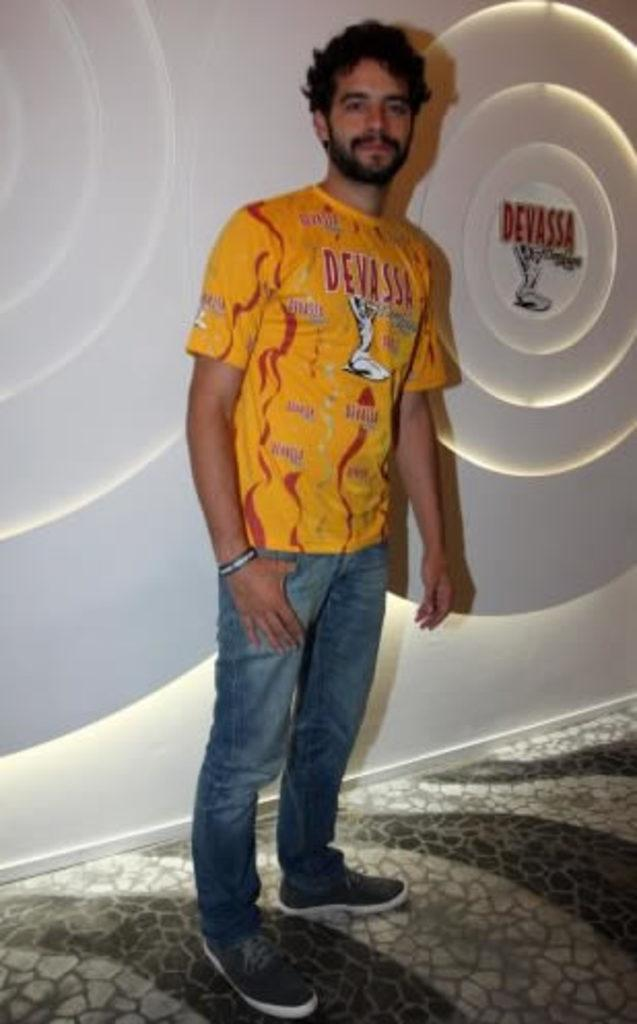What is the main subject of the image? There is a person standing in the center of the image. What is the person's position in relation to the ground? The person is standing on the floor. What can be seen in the background of the image? There is a wall in the background of the image. What type of plantation can be seen in the image? There is no plantation present in the image; it features a person standing on the floor with a wall in the background. What sound can be heard coming from the person in the image? The image is silent, so no sound can be heard. 